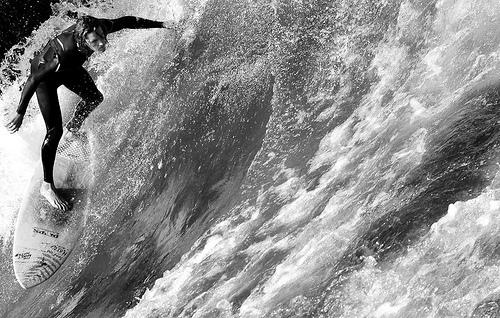Question: where is this man?
Choices:
A. A park.
B. A game.
C. Museum.
D. An ocean.
Answer with the letter. Answer: D Question: what is the man doing?
Choices:
A. Walking.
B. Surfing.
C. Running.
D. Swimming.
Answer with the letter. Answer: B Question: what is the man standing on?
Choices:
A. The sidewalk.
B. A chair.
C. A skateboard.
D. Surfboard.
Answer with the letter. Answer: D Question: who is the man?
Choices:
A. A skater.
B. A hockey player.
C. A surfer.
D. A football receiver.
Answer with the letter. Answer: C Question: what is the man doing with his arms?
Choices:
A. Uses them to balance.
B. Flapping them.
C. Holding a box.
D. Reaching down.
Answer with the letter. Answer: A 